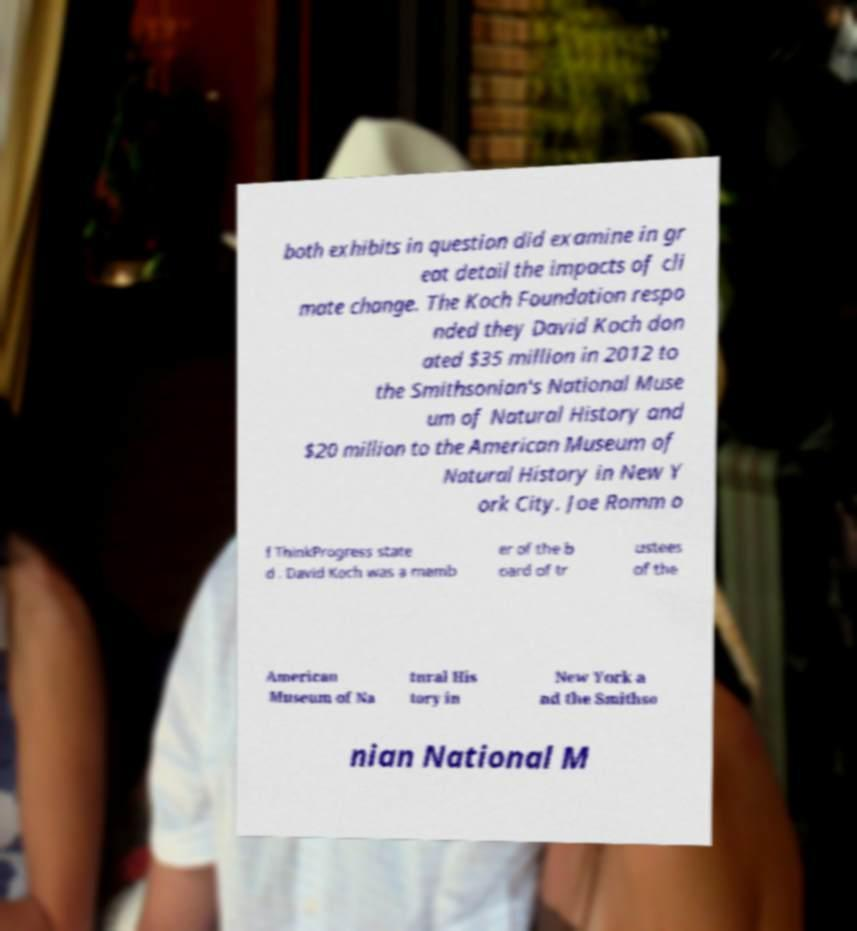Can you accurately transcribe the text from the provided image for me? both exhibits in question did examine in gr eat detail the impacts of cli mate change. The Koch Foundation respo nded they David Koch don ated $35 million in 2012 to the Smithsonian's National Muse um of Natural History and $20 million to the American Museum of Natural History in New Y ork City. Joe Romm o f ThinkProgress state d . David Koch was a memb er of the b oard of tr ustees of the American Museum of Na tural His tory in New York a nd the Smithso nian National M 